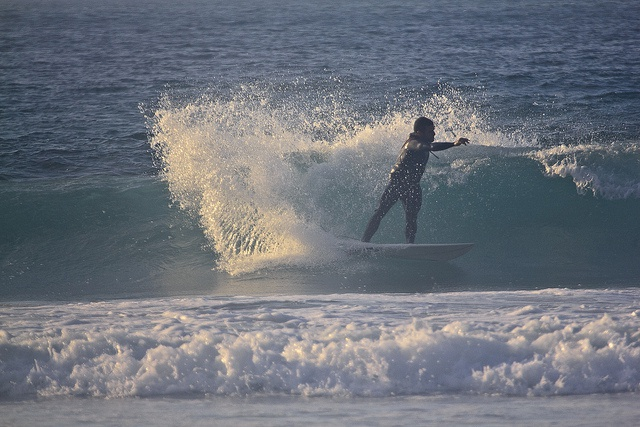Describe the objects in this image and their specific colors. I can see people in gray and black tones and surfboard in gray and darkblue tones in this image. 